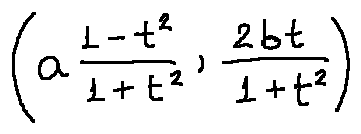<formula> <loc_0><loc_0><loc_500><loc_500>( a \frac { 1 - t ^ { 2 } } { 1 + t ^ { 2 } } , \frac { 2 b t } { 1 + t ^ { 2 } } )</formula> 